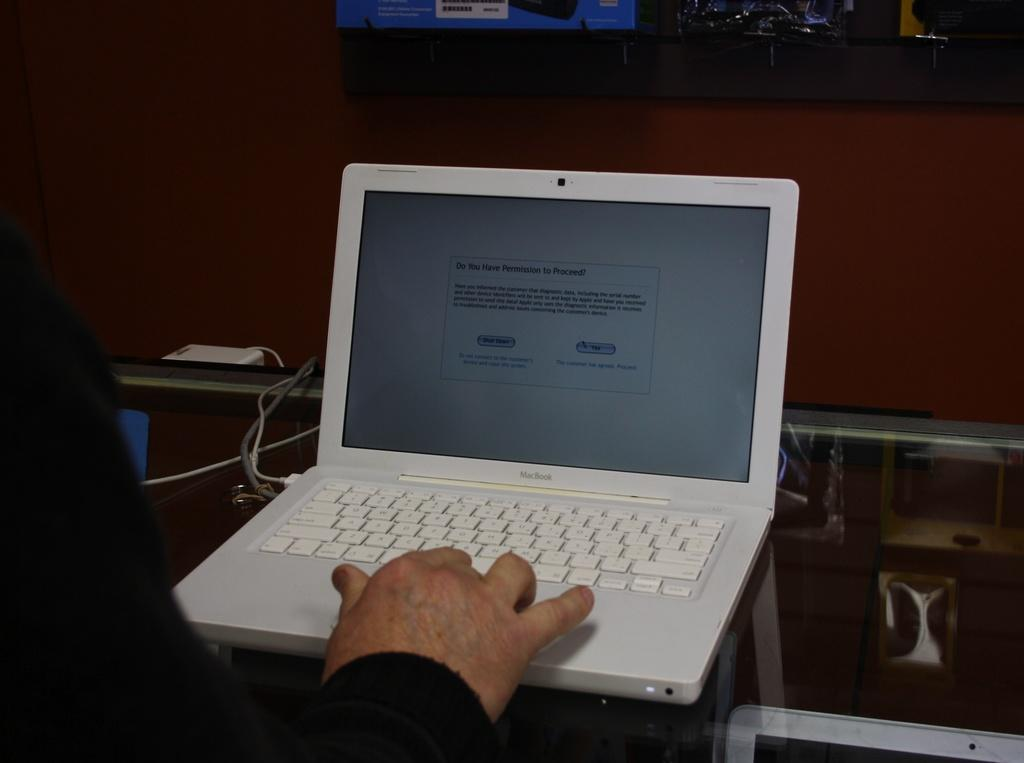Provide a one-sentence caption for the provided image. The computer is offering two options, shut down or yes. 